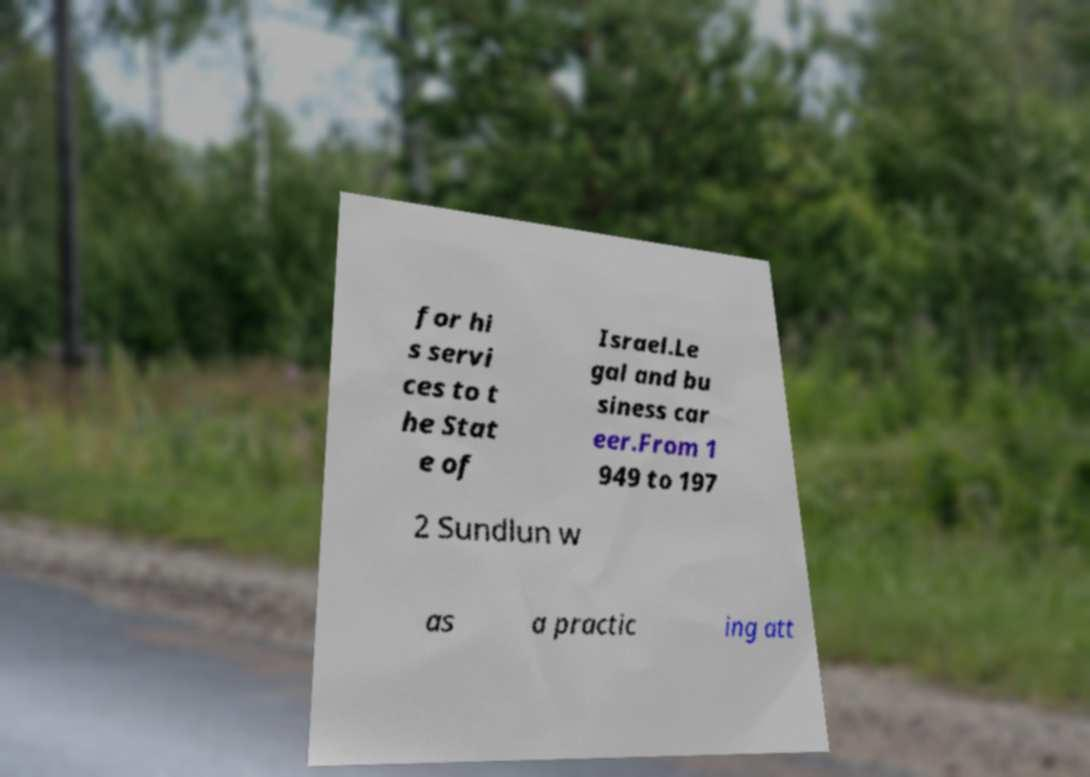There's text embedded in this image that I need extracted. Can you transcribe it verbatim? for hi s servi ces to t he Stat e of Israel.Le gal and bu siness car eer.From 1 949 to 197 2 Sundlun w as a practic ing att 